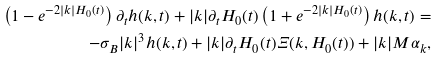<formula> <loc_0><loc_0><loc_500><loc_500>\left ( 1 - e ^ { - 2 | k | H _ { 0 } ( t ) } \right ) \partial _ { t } h ( k , t ) + | k | \partial _ { t } H _ { 0 } ( t ) \left ( 1 + e ^ { - 2 | k | H _ { 0 } ( t ) } \right ) h ( k , t ) = \\ - \sigma _ { B } | k | ^ { 3 } h ( k , t ) + | k | \partial _ { t } H _ { 0 } ( t ) \Xi ( k , H _ { 0 } ( t ) ) + | k | M \alpha _ { k } ,</formula> 